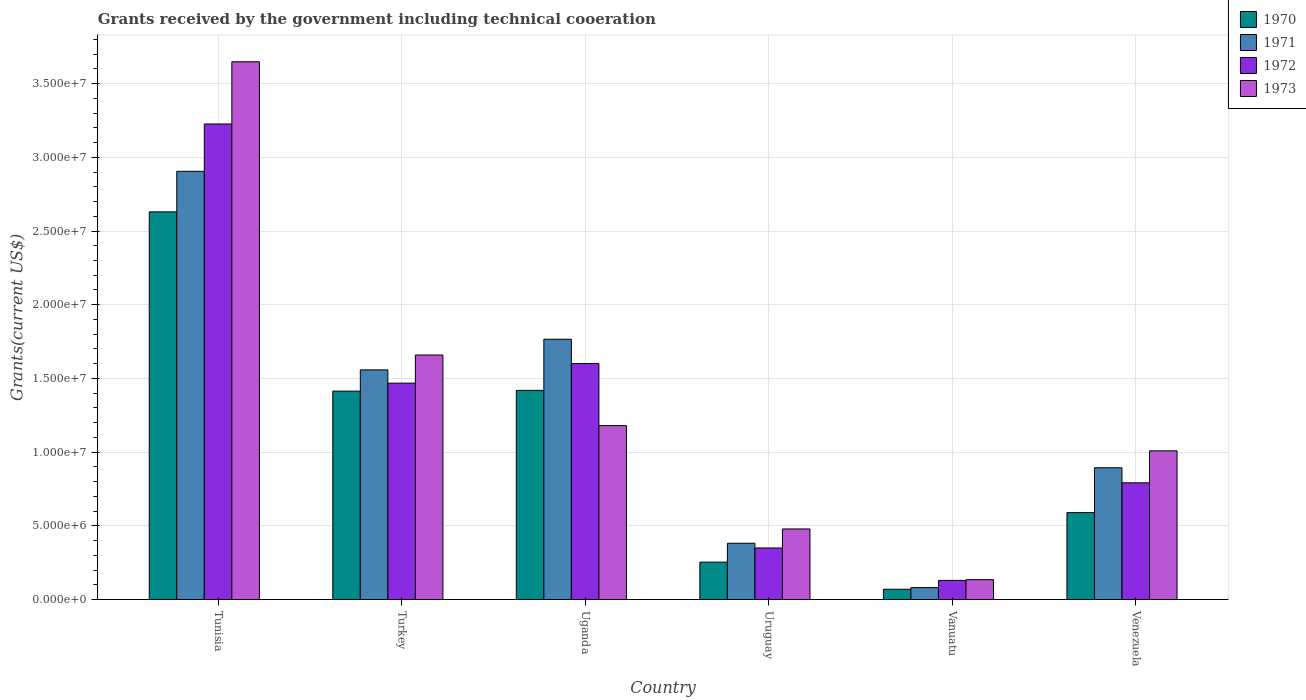How many groups of bars are there?
Provide a succinct answer. 6. Are the number of bars per tick equal to the number of legend labels?
Give a very brief answer. Yes. Are the number of bars on each tick of the X-axis equal?
Give a very brief answer. Yes. How many bars are there on the 4th tick from the right?
Your answer should be very brief. 4. What is the label of the 6th group of bars from the left?
Your answer should be very brief. Venezuela. What is the total grants received by the government in 1973 in Turkey?
Provide a succinct answer. 1.66e+07. Across all countries, what is the maximum total grants received by the government in 1973?
Your response must be concise. 3.65e+07. Across all countries, what is the minimum total grants received by the government in 1973?
Provide a succinct answer. 1.35e+06. In which country was the total grants received by the government in 1970 maximum?
Give a very brief answer. Tunisia. In which country was the total grants received by the government in 1972 minimum?
Provide a short and direct response. Vanuatu. What is the total total grants received by the government in 1973 in the graph?
Your response must be concise. 8.11e+07. What is the difference between the total grants received by the government in 1972 in Turkey and that in Vanuatu?
Provide a succinct answer. 1.34e+07. What is the difference between the total grants received by the government in 1973 in Uruguay and the total grants received by the government in 1970 in Venezuela?
Your response must be concise. -1.11e+06. What is the average total grants received by the government in 1973 per country?
Your answer should be very brief. 1.35e+07. In how many countries, is the total grants received by the government in 1971 greater than 2000000 US$?
Ensure brevity in your answer.  5. What is the ratio of the total grants received by the government in 1972 in Turkey to that in Venezuela?
Make the answer very short. 1.85. Is the total grants received by the government in 1972 in Tunisia less than that in Uganda?
Your response must be concise. No. What is the difference between the highest and the second highest total grants received by the government in 1973?
Ensure brevity in your answer.  1.99e+07. What is the difference between the highest and the lowest total grants received by the government in 1970?
Offer a terse response. 2.56e+07. In how many countries, is the total grants received by the government in 1971 greater than the average total grants received by the government in 1971 taken over all countries?
Offer a very short reply. 3. Is the sum of the total grants received by the government in 1971 in Tunisia and Uruguay greater than the maximum total grants received by the government in 1972 across all countries?
Offer a terse response. Yes. Are the values on the major ticks of Y-axis written in scientific E-notation?
Make the answer very short. Yes. Does the graph contain any zero values?
Your response must be concise. No. Where does the legend appear in the graph?
Your answer should be very brief. Top right. What is the title of the graph?
Provide a short and direct response. Grants received by the government including technical cooeration. Does "1982" appear as one of the legend labels in the graph?
Provide a short and direct response. No. What is the label or title of the Y-axis?
Your answer should be very brief. Grants(current US$). What is the Grants(current US$) in 1970 in Tunisia?
Your answer should be very brief. 2.63e+07. What is the Grants(current US$) in 1971 in Tunisia?
Provide a succinct answer. 2.90e+07. What is the Grants(current US$) of 1972 in Tunisia?
Provide a short and direct response. 3.23e+07. What is the Grants(current US$) of 1973 in Tunisia?
Keep it short and to the point. 3.65e+07. What is the Grants(current US$) of 1970 in Turkey?
Provide a succinct answer. 1.41e+07. What is the Grants(current US$) in 1971 in Turkey?
Your response must be concise. 1.56e+07. What is the Grants(current US$) of 1972 in Turkey?
Make the answer very short. 1.47e+07. What is the Grants(current US$) in 1973 in Turkey?
Offer a terse response. 1.66e+07. What is the Grants(current US$) of 1970 in Uganda?
Your answer should be compact. 1.42e+07. What is the Grants(current US$) of 1971 in Uganda?
Give a very brief answer. 1.77e+07. What is the Grants(current US$) of 1972 in Uganda?
Provide a succinct answer. 1.60e+07. What is the Grants(current US$) in 1973 in Uganda?
Give a very brief answer. 1.18e+07. What is the Grants(current US$) in 1970 in Uruguay?
Provide a short and direct response. 2.54e+06. What is the Grants(current US$) in 1971 in Uruguay?
Give a very brief answer. 3.82e+06. What is the Grants(current US$) in 1972 in Uruguay?
Provide a succinct answer. 3.50e+06. What is the Grants(current US$) of 1973 in Uruguay?
Make the answer very short. 4.79e+06. What is the Grants(current US$) of 1970 in Vanuatu?
Offer a very short reply. 7.00e+05. What is the Grants(current US$) in 1971 in Vanuatu?
Your answer should be compact. 8.10e+05. What is the Grants(current US$) of 1972 in Vanuatu?
Offer a terse response. 1.30e+06. What is the Grants(current US$) of 1973 in Vanuatu?
Offer a very short reply. 1.35e+06. What is the Grants(current US$) of 1970 in Venezuela?
Provide a short and direct response. 5.90e+06. What is the Grants(current US$) in 1971 in Venezuela?
Your answer should be very brief. 8.94e+06. What is the Grants(current US$) of 1972 in Venezuela?
Keep it short and to the point. 7.92e+06. What is the Grants(current US$) in 1973 in Venezuela?
Your answer should be very brief. 1.01e+07. Across all countries, what is the maximum Grants(current US$) in 1970?
Your answer should be very brief. 2.63e+07. Across all countries, what is the maximum Grants(current US$) in 1971?
Your answer should be compact. 2.90e+07. Across all countries, what is the maximum Grants(current US$) of 1972?
Provide a succinct answer. 3.23e+07. Across all countries, what is the maximum Grants(current US$) in 1973?
Your answer should be very brief. 3.65e+07. Across all countries, what is the minimum Grants(current US$) of 1970?
Offer a very short reply. 7.00e+05. Across all countries, what is the minimum Grants(current US$) in 1971?
Your answer should be compact. 8.10e+05. Across all countries, what is the minimum Grants(current US$) of 1972?
Your answer should be compact. 1.30e+06. Across all countries, what is the minimum Grants(current US$) of 1973?
Your response must be concise. 1.35e+06. What is the total Grants(current US$) in 1970 in the graph?
Offer a terse response. 6.38e+07. What is the total Grants(current US$) of 1971 in the graph?
Provide a short and direct response. 7.59e+07. What is the total Grants(current US$) of 1972 in the graph?
Your response must be concise. 7.57e+07. What is the total Grants(current US$) of 1973 in the graph?
Give a very brief answer. 8.11e+07. What is the difference between the Grants(current US$) in 1970 in Tunisia and that in Turkey?
Offer a terse response. 1.22e+07. What is the difference between the Grants(current US$) of 1971 in Tunisia and that in Turkey?
Keep it short and to the point. 1.35e+07. What is the difference between the Grants(current US$) in 1972 in Tunisia and that in Turkey?
Provide a succinct answer. 1.76e+07. What is the difference between the Grants(current US$) in 1973 in Tunisia and that in Turkey?
Offer a very short reply. 1.99e+07. What is the difference between the Grants(current US$) in 1970 in Tunisia and that in Uganda?
Offer a very short reply. 1.21e+07. What is the difference between the Grants(current US$) of 1971 in Tunisia and that in Uganda?
Give a very brief answer. 1.14e+07. What is the difference between the Grants(current US$) of 1972 in Tunisia and that in Uganda?
Provide a succinct answer. 1.62e+07. What is the difference between the Grants(current US$) in 1973 in Tunisia and that in Uganda?
Your response must be concise. 2.47e+07. What is the difference between the Grants(current US$) of 1970 in Tunisia and that in Uruguay?
Your response must be concise. 2.38e+07. What is the difference between the Grants(current US$) of 1971 in Tunisia and that in Uruguay?
Your answer should be very brief. 2.52e+07. What is the difference between the Grants(current US$) of 1972 in Tunisia and that in Uruguay?
Ensure brevity in your answer.  2.88e+07. What is the difference between the Grants(current US$) of 1973 in Tunisia and that in Uruguay?
Make the answer very short. 3.17e+07. What is the difference between the Grants(current US$) in 1970 in Tunisia and that in Vanuatu?
Give a very brief answer. 2.56e+07. What is the difference between the Grants(current US$) in 1971 in Tunisia and that in Vanuatu?
Your answer should be very brief. 2.82e+07. What is the difference between the Grants(current US$) in 1972 in Tunisia and that in Vanuatu?
Offer a very short reply. 3.10e+07. What is the difference between the Grants(current US$) of 1973 in Tunisia and that in Vanuatu?
Your answer should be compact. 3.51e+07. What is the difference between the Grants(current US$) of 1970 in Tunisia and that in Venezuela?
Your response must be concise. 2.04e+07. What is the difference between the Grants(current US$) in 1971 in Tunisia and that in Venezuela?
Your answer should be compact. 2.01e+07. What is the difference between the Grants(current US$) of 1972 in Tunisia and that in Venezuela?
Ensure brevity in your answer.  2.43e+07. What is the difference between the Grants(current US$) in 1973 in Tunisia and that in Venezuela?
Give a very brief answer. 2.64e+07. What is the difference between the Grants(current US$) of 1971 in Turkey and that in Uganda?
Your answer should be very brief. -2.08e+06. What is the difference between the Grants(current US$) in 1972 in Turkey and that in Uganda?
Ensure brevity in your answer.  -1.33e+06. What is the difference between the Grants(current US$) of 1973 in Turkey and that in Uganda?
Provide a succinct answer. 4.79e+06. What is the difference between the Grants(current US$) in 1970 in Turkey and that in Uruguay?
Provide a succinct answer. 1.16e+07. What is the difference between the Grants(current US$) of 1971 in Turkey and that in Uruguay?
Provide a short and direct response. 1.18e+07. What is the difference between the Grants(current US$) in 1972 in Turkey and that in Uruguay?
Provide a short and direct response. 1.12e+07. What is the difference between the Grants(current US$) of 1973 in Turkey and that in Uruguay?
Provide a succinct answer. 1.18e+07. What is the difference between the Grants(current US$) in 1970 in Turkey and that in Vanuatu?
Give a very brief answer. 1.34e+07. What is the difference between the Grants(current US$) of 1971 in Turkey and that in Vanuatu?
Your answer should be very brief. 1.48e+07. What is the difference between the Grants(current US$) of 1972 in Turkey and that in Vanuatu?
Your answer should be very brief. 1.34e+07. What is the difference between the Grants(current US$) in 1973 in Turkey and that in Vanuatu?
Your answer should be compact. 1.52e+07. What is the difference between the Grants(current US$) in 1970 in Turkey and that in Venezuela?
Provide a short and direct response. 8.24e+06. What is the difference between the Grants(current US$) in 1971 in Turkey and that in Venezuela?
Give a very brief answer. 6.64e+06. What is the difference between the Grants(current US$) in 1972 in Turkey and that in Venezuela?
Your response must be concise. 6.76e+06. What is the difference between the Grants(current US$) in 1973 in Turkey and that in Venezuela?
Offer a very short reply. 6.50e+06. What is the difference between the Grants(current US$) of 1970 in Uganda and that in Uruguay?
Keep it short and to the point. 1.16e+07. What is the difference between the Grants(current US$) in 1971 in Uganda and that in Uruguay?
Your answer should be very brief. 1.38e+07. What is the difference between the Grants(current US$) of 1972 in Uganda and that in Uruguay?
Your answer should be compact. 1.25e+07. What is the difference between the Grants(current US$) of 1973 in Uganda and that in Uruguay?
Provide a short and direct response. 7.01e+06. What is the difference between the Grants(current US$) in 1970 in Uganda and that in Vanuatu?
Your answer should be very brief. 1.35e+07. What is the difference between the Grants(current US$) in 1971 in Uganda and that in Vanuatu?
Offer a terse response. 1.68e+07. What is the difference between the Grants(current US$) in 1972 in Uganda and that in Vanuatu?
Your response must be concise. 1.47e+07. What is the difference between the Grants(current US$) of 1973 in Uganda and that in Vanuatu?
Your response must be concise. 1.04e+07. What is the difference between the Grants(current US$) of 1970 in Uganda and that in Venezuela?
Keep it short and to the point. 8.29e+06. What is the difference between the Grants(current US$) in 1971 in Uganda and that in Venezuela?
Keep it short and to the point. 8.72e+06. What is the difference between the Grants(current US$) of 1972 in Uganda and that in Venezuela?
Your answer should be very brief. 8.09e+06. What is the difference between the Grants(current US$) of 1973 in Uganda and that in Venezuela?
Your response must be concise. 1.71e+06. What is the difference between the Grants(current US$) of 1970 in Uruguay and that in Vanuatu?
Give a very brief answer. 1.84e+06. What is the difference between the Grants(current US$) in 1971 in Uruguay and that in Vanuatu?
Provide a short and direct response. 3.01e+06. What is the difference between the Grants(current US$) in 1972 in Uruguay and that in Vanuatu?
Give a very brief answer. 2.20e+06. What is the difference between the Grants(current US$) of 1973 in Uruguay and that in Vanuatu?
Make the answer very short. 3.44e+06. What is the difference between the Grants(current US$) of 1970 in Uruguay and that in Venezuela?
Your answer should be compact. -3.36e+06. What is the difference between the Grants(current US$) in 1971 in Uruguay and that in Venezuela?
Give a very brief answer. -5.12e+06. What is the difference between the Grants(current US$) of 1972 in Uruguay and that in Venezuela?
Ensure brevity in your answer.  -4.42e+06. What is the difference between the Grants(current US$) of 1973 in Uruguay and that in Venezuela?
Your response must be concise. -5.30e+06. What is the difference between the Grants(current US$) of 1970 in Vanuatu and that in Venezuela?
Offer a very short reply. -5.20e+06. What is the difference between the Grants(current US$) in 1971 in Vanuatu and that in Venezuela?
Your answer should be very brief. -8.13e+06. What is the difference between the Grants(current US$) in 1972 in Vanuatu and that in Venezuela?
Provide a short and direct response. -6.62e+06. What is the difference between the Grants(current US$) of 1973 in Vanuatu and that in Venezuela?
Make the answer very short. -8.74e+06. What is the difference between the Grants(current US$) of 1970 in Tunisia and the Grants(current US$) of 1971 in Turkey?
Keep it short and to the point. 1.07e+07. What is the difference between the Grants(current US$) in 1970 in Tunisia and the Grants(current US$) in 1972 in Turkey?
Offer a very short reply. 1.16e+07. What is the difference between the Grants(current US$) of 1970 in Tunisia and the Grants(current US$) of 1973 in Turkey?
Offer a very short reply. 9.71e+06. What is the difference between the Grants(current US$) in 1971 in Tunisia and the Grants(current US$) in 1972 in Turkey?
Offer a very short reply. 1.44e+07. What is the difference between the Grants(current US$) in 1971 in Tunisia and the Grants(current US$) in 1973 in Turkey?
Give a very brief answer. 1.25e+07. What is the difference between the Grants(current US$) of 1972 in Tunisia and the Grants(current US$) of 1973 in Turkey?
Keep it short and to the point. 1.57e+07. What is the difference between the Grants(current US$) of 1970 in Tunisia and the Grants(current US$) of 1971 in Uganda?
Provide a succinct answer. 8.64e+06. What is the difference between the Grants(current US$) of 1970 in Tunisia and the Grants(current US$) of 1972 in Uganda?
Your answer should be very brief. 1.03e+07. What is the difference between the Grants(current US$) in 1970 in Tunisia and the Grants(current US$) in 1973 in Uganda?
Your response must be concise. 1.45e+07. What is the difference between the Grants(current US$) in 1971 in Tunisia and the Grants(current US$) in 1972 in Uganda?
Make the answer very short. 1.30e+07. What is the difference between the Grants(current US$) in 1971 in Tunisia and the Grants(current US$) in 1973 in Uganda?
Give a very brief answer. 1.72e+07. What is the difference between the Grants(current US$) in 1972 in Tunisia and the Grants(current US$) in 1973 in Uganda?
Keep it short and to the point. 2.05e+07. What is the difference between the Grants(current US$) in 1970 in Tunisia and the Grants(current US$) in 1971 in Uruguay?
Offer a very short reply. 2.25e+07. What is the difference between the Grants(current US$) of 1970 in Tunisia and the Grants(current US$) of 1972 in Uruguay?
Make the answer very short. 2.28e+07. What is the difference between the Grants(current US$) in 1970 in Tunisia and the Grants(current US$) in 1973 in Uruguay?
Your answer should be compact. 2.15e+07. What is the difference between the Grants(current US$) in 1971 in Tunisia and the Grants(current US$) in 1972 in Uruguay?
Your answer should be very brief. 2.56e+07. What is the difference between the Grants(current US$) of 1971 in Tunisia and the Grants(current US$) of 1973 in Uruguay?
Your answer should be very brief. 2.43e+07. What is the difference between the Grants(current US$) in 1972 in Tunisia and the Grants(current US$) in 1973 in Uruguay?
Your response must be concise. 2.75e+07. What is the difference between the Grants(current US$) of 1970 in Tunisia and the Grants(current US$) of 1971 in Vanuatu?
Keep it short and to the point. 2.55e+07. What is the difference between the Grants(current US$) in 1970 in Tunisia and the Grants(current US$) in 1972 in Vanuatu?
Offer a very short reply. 2.50e+07. What is the difference between the Grants(current US$) in 1970 in Tunisia and the Grants(current US$) in 1973 in Vanuatu?
Offer a very short reply. 2.50e+07. What is the difference between the Grants(current US$) of 1971 in Tunisia and the Grants(current US$) of 1972 in Vanuatu?
Ensure brevity in your answer.  2.78e+07. What is the difference between the Grants(current US$) in 1971 in Tunisia and the Grants(current US$) in 1973 in Vanuatu?
Ensure brevity in your answer.  2.77e+07. What is the difference between the Grants(current US$) of 1972 in Tunisia and the Grants(current US$) of 1973 in Vanuatu?
Make the answer very short. 3.09e+07. What is the difference between the Grants(current US$) in 1970 in Tunisia and the Grants(current US$) in 1971 in Venezuela?
Ensure brevity in your answer.  1.74e+07. What is the difference between the Grants(current US$) of 1970 in Tunisia and the Grants(current US$) of 1972 in Venezuela?
Your response must be concise. 1.84e+07. What is the difference between the Grants(current US$) of 1970 in Tunisia and the Grants(current US$) of 1973 in Venezuela?
Ensure brevity in your answer.  1.62e+07. What is the difference between the Grants(current US$) of 1971 in Tunisia and the Grants(current US$) of 1972 in Venezuela?
Provide a short and direct response. 2.11e+07. What is the difference between the Grants(current US$) in 1971 in Tunisia and the Grants(current US$) in 1973 in Venezuela?
Offer a terse response. 1.90e+07. What is the difference between the Grants(current US$) of 1972 in Tunisia and the Grants(current US$) of 1973 in Venezuela?
Give a very brief answer. 2.22e+07. What is the difference between the Grants(current US$) of 1970 in Turkey and the Grants(current US$) of 1971 in Uganda?
Your response must be concise. -3.52e+06. What is the difference between the Grants(current US$) in 1970 in Turkey and the Grants(current US$) in 1972 in Uganda?
Provide a succinct answer. -1.87e+06. What is the difference between the Grants(current US$) of 1970 in Turkey and the Grants(current US$) of 1973 in Uganda?
Your response must be concise. 2.34e+06. What is the difference between the Grants(current US$) of 1971 in Turkey and the Grants(current US$) of 1972 in Uganda?
Make the answer very short. -4.30e+05. What is the difference between the Grants(current US$) in 1971 in Turkey and the Grants(current US$) in 1973 in Uganda?
Your answer should be compact. 3.78e+06. What is the difference between the Grants(current US$) of 1972 in Turkey and the Grants(current US$) of 1973 in Uganda?
Ensure brevity in your answer.  2.88e+06. What is the difference between the Grants(current US$) of 1970 in Turkey and the Grants(current US$) of 1971 in Uruguay?
Offer a very short reply. 1.03e+07. What is the difference between the Grants(current US$) in 1970 in Turkey and the Grants(current US$) in 1972 in Uruguay?
Offer a very short reply. 1.06e+07. What is the difference between the Grants(current US$) in 1970 in Turkey and the Grants(current US$) in 1973 in Uruguay?
Offer a very short reply. 9.35e+06. What is the difference between the Grants(current US$) in 1971 in Turkey and the Grants(current US$) in 1972 in Uruguay?
Provide a succinct answer. 1.21e+07. What is the difference between the Grants(current US$) in 1971 in Turkey and the Grants(current US$) in 1973 in Uruguay?
Keep it short and to the point. 1.08e+07. What is the difference between the Grants(current US$) of 1972 in Turkey and the Grants(current US$) of 1973 in Uruguay?
Ensure brevity in your answer.  9.89e+06. What is the difference between the Grants(current US$) of 1970 in Turkey and the Grants(current US$) of 1971 in Vanuatu?
Offer a very short reply. 1.33e+07. What is the difference between the Grants(current US$) of 1970 in Turkey and the Grants(current US$) of 1972 in Vanuatu?
Your answer should be compact. 1.28e+07. What is the difference between the Grants(current US$) of 1970 in Turkey and the Grants(current US$) of 1973 in Vanuatu?
Make the answer very short. 1.28e+07. What is the difference between the Grants(current US$) of 1971 in Turkey and the Grants(current US$) of 1972 in Vanuatu?
Your answer should be very brief. 1.43e+07. What is the difference between the Grants(current US$) in 1971 in Turkey and the Grants(current US$) in 1973 in Vanuatu?
Provide a short and direct response. 1.42e+07. What is the difference between the Grants(current US$) in 1972 in Turkey and the Grants(current US$) in 1973 in Vanuatu?
Your answer should be compact. 1.33e+07. What is the difference between the Grants(current US$) of 1970 in Turkey and the Grants(current US$) of 1971 in Venezuela?
Make the answer very short. 5.20e+06. What is the difference between the Grants(current US$) in 1970 in Turkey and the Grants(current US$) in 1972 in Venezuela?
Your answer should be very brief. 6.22e+06. What is the difference between the Grants(current US$) in 1970 in Turkey and the Grants(current US$) in 1973 in Venezuela?
Provide a short and direct response. 4.05e+06. What is the difference between the Grants(current US$) in 1971 in Turkey and the Grants(current US$) in 1972 in Venezuela?
Give a very brief answer. 7.66e+06. What is the difference between the Grants(current US$) in 1971 in Turkey and the Grants(current US$) in 1973 in Venezuela?
Ensure brevity in your answer.  5.49e+06. What is the difference between the Grants(current US$) in 1972 in Turkey and the Grants(current US$) in 1973 in Venezuela?
Ensure brevity in your answer.  4.59e+06. What is the difference between the Grants(current US$) of 1970 in Uganda and the Grants(current US$) of 1971 in Uruguay?
Your response must be concise. 1.04e+07. What is the difference between the Grants(current US$) of 1970 in Uganda and the Grants(current US$) of 1972 in Uruguay?
Keep it short and to the point. 1.07e+07. What is the difference between the Grants(current US$) of 1970 in Uganda and the Grants(current US$) of 1973 in Uruguay?
Ensure brevity in your answer.  9.40e+06. What is the difference between the Grants(current US$) of 1971 in Uganda and the Grants(current US$) of 1972 in Uruguay?
Ensure brevity in your answer.  1.42e+07. What is the difference between the Grants(current US$) in 1971 in Uganda and the Grants(current US$) in 1973 in Uruguay?
Ensure brevity in your answer.  1.29e+07. What is the difference between the Grants(current US$) of 1972 in Uganda and the Grants(current US$) of 1973 in Uruguay?
Your answer should be compact. 1.12e+07. What is the difference between the Grants(current US$) in 1970 in Uganda and the Grants(current US$) in 1971 in Vanuatu?
Provide a short and direct response. 1.34e+07. What is the difference between the Grants(current US$) of 1970 in Uganda and the Grants(current US$) of 1972 in Vanuatu?
Your answer should be very brief. 1.29e+07. What is the difference between the Grants(current US$) in 1970 in Uganda and the Grants(current US$) in 1973 in Vanuatu?
Offer a very short reply. 1.28e+07. What is the difference between the Grants(current US$) in 1971 in Uganda and the Grants(current US$) in 1972 in Vanuatu?
Your answer should be very brief. 1.64e+07. What is the difference between the Grants(current US$) of 1971 in Uganda and the Grants(current US$) of 1973 in Vanuatu?
Provide a succinct answer. 1.63e+07. What is the difference between the Grants(current US$) of 1972 in Uganda and the Grants(current US$) of 1973 in Vanuatu?
Your answer should be very brief. 1.47e+07. What is the difference between the Grants(current US$) in 1970 in Uganda and the Grants(current US$) in 1971 in Venezuela?
Ensure brevity in your answer.  5.25e+06. What is the difference between the Grants(current US$) of 1970 in Uganda and the Grants(current US$) of 1972 in Venezuela?
Provide a succinct answer. 6.27e+06. What is the difference between the Grants(current US$) of 1970 in Uganda and the Grants(current US$) of 1973 in Venezuela?
Make the answer very short. 4.10e+06. What is the difference between the Grants(current US$) of 1971 in Uganda and the Grants(current US$) of 1972 in Venezuela?
Provide a short and direct response. 9.74e+06. What is the difference between the Grants(current US$) of 1971 in Uganda and the Grants(current US$) of 1973 in Venezuela?
Your response must be concise. 7.57e+06. What is the difference between the Grants(current US$) in 1972 in Uganda and the Grants(current US$) in 1973 in Venezuela?
Keep it short and to the point. 5.92e+06. What is the difference between the Grants(current US$) in 1970 in Uruguay and the Grants(current US$) in 1971 in Vanuatu?
Your response must be concise. 1.73e+06. What is the difference between the Grants(current US$) of 1970 in Uruguay and the Grants(current US$) of 1972 in Vanuatu?
Keep it short and to the point. 1.24e+06. What is the difference between the Grants(current US$) in 1970 in Uruguay and the Grants(current US$) in 1973 in Vanuatu?
Offer a very short reply. 1.19e+06. What is the difference between the Grants(current US$) in 1971 in Uruguay and the Grants(current US$) in 1972 in Vanuatu?
Give a very brief answer. 2.52e+06. What is the difference between the Grants(current US$) of 1971 in Uruguay and the Grants(current US$) of 1973 in Vanuatu?
Give a very brief answer. 2.47e+06. What is the difference between the Grants(current US$) of 1972 in Uruguay and the Grants(current US$) of 1973 in Vanuatu?
Your answer should be very brief. 2.15e+06. What is the difference between the Grants(current US$) in 1970 in Uruguay and the Grants(current US$) in 1971 in Venezuela?
Your response must be concise. -6.40e+06. What is the difference between the Grants(current US$) of 1970 in Uruguay and the Grants(current US$) of 1972 in Venezuela?
Offer a terse response. -5.38e+06. What is the difference between the Grants(current US$) in 1970 in Uruguay and the Grants(current US$) in 1973 in Venezuela?
Your answer should be compact. -7.55e+06. What is the difference between the Grants(current US$) of 1971 in Uruguay and the Grants(current US$) of 1972 in Venezuela?
Offer a very short reply. -4.10e+06. What is the difference between the Grants(current US$) in 1971 in Uruguay and the Grants(current US$) in 1973 in Venezuela?
Your response must be concise. -6.27e+06. What is the difference between the Grants(current US$) in 1972 in Uruguay and the Grants(current US$) in 1973 in Venezuela?
Provide a short and direct response. -6.59e+06. What is the difference between the Grants(current US$) in 1970 in Vanuatu and the Grants(current US$) in 1971 in Venezuela?
Provide a succinct answer. -8.24e+06. What is the difference between the Grants(current US$) in 1970 in Vanuatu and the Grants(current US$) in 1972 in Venezuela?
Ensure brevity in your answer.  -7.22e+06. What is the difference between the Grants(current US$) of 1970 in Vanuatu and the Grants(current US$) of 1973 in Venezuela?
Your answer should be compact. -9.39e+06. What is the difference between the Grants(current US$) of 1971 in Vanuatu and the Grants(current US$) of 1972 in Venezuela?
Provide a succinct answer. -7.11e+06. What is the difference between the Grants(current US$) of 1971 in Vanuatu and the Grants(current US$) of 1973 in Venezuela?
Offer a very short reply. -9.28e+06. What is the difference between the Grants(current US$) in 1972 in Vanuatu and the Grants(current US$) in 1973 in Venezuela?
Your answer should be very brief. -8.79e+06. What is the average Grants(current US$) of 1970 per country?
Offer a terse response. 1.06e+07. What is the average Grants(current US$) in 1971 per country?
Your response must be concise. 1.26e+07. What is the average Grants(current US$) of 1972 per country?
Your answer should be compact. 1.26e+07. What is the average Grants(current US$) in 1973 per country?
Offer a terse response. 1.35e+07. What is the difference between the Grants(current US$) of 1970 and Grants(current US$) of 1971 in Tunisia?
Give a very brief answer. -2.75e+06. What is the difference between the Grants(current US$) in 1970 and Grants(current US$) in 1972 in Tunisia?
Your response must be concise. -5.96e+06. What is the difference between the Grants(current US$) in 1970 and Grants(current US$) in 1973 in Tunisia?
Give a very brief answer. -1.02e+07. What is the difference between the Grants(current US$) of 1971 and Grants(current US$) of 1972 in Tunisia?
Your answer should be compact. -3.21e+06. What is the difference between the Grants(current US$) in 1971 and Grants(current US$) in 1973 in Tunisia?
Your answer should be compact. -7.43e+06. What is the difference between the Grants(current US$) in 1972 and Grants(current US$) in 1973 in Tunisia?
Give a very brief answer. -4.22e+06. What is the difference between the Grants(current US$) of 1970 and Grants(current US$) of 1971 in Turkey?
Ensure brevity in your answer.  -1.44e+06. What is the difference between the Grants(current US$) in 1970 and Grants(current US$) in 1972 in Turkey?
Your answer should be compact. -5.40e+05. What is the difference between the Grants(current US$) of 1970 and Grants(current US$) of 1973 in Turkey?
Ensure brevity in your answer.  -2.45e+06. What is the difference between the Grants(current US$) in 1971 and Grants(current US$) in 1973 in Turkey?
Offer a very short reply. -1.01e+06. What is the difference between the Grants(current US$) of 1972 and Grants(current US$) of 1973 in Turkey?
Your answer should be very brief. -1.91e+06. What is the difference between the Grants(current US$) in 1970 and Grants(current US$) in 1971 in Uganda?
Your response must be concise. -3.47e+06. What is the difference between the Grants(current US$) of 1970 and Grants(current US$) of 1972 in Uganda?
Provide a succinct answer. -1.82e+06. What is the difference between the Grants(current US$) of 1970 and Grants(current US$) of 1973 in Uganda?
Ensure brevity in your answer.  2.39e+06. What is the difference between the Grants(current US$) of 1971 and Grants(current US$) of 1972 in Uganda?
Offer a terse response. 1.65e+06. What is the difference between the Grants(current US$) of 1971 and Grants(current US$) of 1973 in Uganda?
Your response must be concise. 5.86e+06. What is the difference between the Grants(current US$) in 1972 and Grants(current US$) in 1973 in Uganda?
Provide a succinct answer. 4.21e+06. What is the difference between the Grants(current US$) of 1970 and Grants(current US$) of 1971 in Uruguay?
Give a very brief answer. -1.28e+06. What is the difference between the Grants(current US$) in 1970 and Grants(current US$) in 1972 in Uruguay?
Provide a short and direct response. -9.60e+05. What is the difference between the Grants(current US$) of 1970 and Grants(current US$) of 1973 in Uruguay?
Your answer should be compact. -2.25e+06. What is the difference between the Grants(current US$) of 1971 and Grants(current US$) of 1972 in Uruguay?
Give a very brief answer. 3.20e+05. What is the difference between the Grants(current US$) in 1971 and Grants(current US$) in 1973 in Uruguay?
Your answer should be very brief. -9.70e+05. What is the difference between the Grants(current US$) of 1972 and Grants(current US$) of 1973 in Uruguay?
Keep it short and to the point. -1.29e+06. What is the difference between the Grants(current US$) in 1970 and Grants(current US$) in 1972 in Vanuatu?
Your response must be concise. -6.00e+05. What is the difference between the Grants(current US$) of 1970 and Grants(current US$) of 1973 in Vanuatu?
Provide a short and direct response. -6.50e+05. What is the difference between the Grants(current US$) in 1971 and Grants(current US$) in 1972 in Vanuatu?
Provide a succinct answer. -4.90e+05. What is the difference between the Grants(current US$) of 1971 and Grants(current US$) of 1973 in Vanuatu?
Provide a short and direct response. -5.40e+05. What is the difference between the Grants(current US$) in 1970 and Grants(current US$) in 1971 in Venezuela?
Offer a terse response. -3.04e+06. What is the difference between the Grants(current US$) of 1970 and Grants(current US$) of 1972 in Venezuela?
Your answer should be compact. -2.02e+06. What is the difference between the Grants(current US$) in 1970 and Grants(current US$) in 1973 in Venezuela?
Offer a terse response. -4.19e+06. What is the difference between the Grants(current US$) of 1971 and Grants(current US$) of 1972 in Venezuela?
Provide a short and direct response. 1.02e+06. What is the difference between the Grants(current US$) in 1971 and Grants(current US$) in 1973 in Venezuela?
Provide a succinct answer. -1.15e+06. What is the difference between the Grants(current US$) of 1972 and Grants(current US$) of 1973 in Venezuela?
Make the answer very short. -2.17e+06. What is the ratio of the Grants(current US$) in 1970 in Tunisia to that in Turkey?
Provide a succinct answer. 1.86. What is the ratio of the Grants(current US$) of 1971 in Tunisia to that in Turkey?
Offer a very short reply. 1.86. What is the ratio of the Grants(current US$) in 1972 in Tunisia to that in Turkey?
Make the answer very short. 2.2. What is the ratio of the Grants(current US$) in 1973 in Tunisia to that in Turkey?
Your response must be concise. 2.2. What is the ratio of the Grants(current US$) in 1970 in Tunisia to that in Uganda?
Offer a very short reply. 1.85. What is the ratio of the Grants(current US$) in 1971 in Tunisia to that in Uganda?
Make the answer very short. 1.65. What is the ratio of the Grants(current US$) of 1972 in Tunisia to that in Uganda?
Offer a very short reply. 2.02. What is the ratio of the Grants(current US$) of 1973 in Tunisia to that in Uganda?
Ensure brevity in your answer.  3.09. What is the ratio of the Grants(current US$) in 1970 in Tunisia to that in Uruguay?
Your answer should be very brief. 10.35. What is the ratio of the Grants(current US$) in 1971 in Tunisia to that in Uruguay?
Provide a succinct answer. 7.6. What is the ratio of the Grants(current US$) in 1972 in Tunisia to that in Uruguay?
Offer a very short reply. 9.22. What is the ratio of the Grants(current US$) in 1973 in Tunisia to that in Uruguay?
Your answer should be very brief. 7.62. What is the ratio of the Grants(current US$) of 1970 in Tunisia to that in Vanuatu?
Your answer should be compact. 37.57. What is the ratio of the Grants(current US$) in 1971 in Tunisia to that in Vanuatu?
Give a very brief answer. 35.86. What is the ratio of the Grants(current US$) of 1972 in Tunisia to that in Vanuatu?
Give a very brief answer. 24.82. What is the ratio of the Grants(current US$) in 1973 in Tunisia to that in Vanuatu?
Provide a succinct answer. 27.02. What is the ratio of the Grants(current US$) in 1970 in Tunisia to that in Venezuela?
Provide a succinct answer. 4.46. What is the ratio of the Grants(current US$) in 1971 in Tunisia to that in Venezuela?
Make the answer very short. 3.25. What is the ratio of the Grants(current US$) of 1972 in Tunisia to that in Venezuela?
Offer a very short reply. 4.07. What is the ratio of the Grants(current US$) of 1973 in Tunisia to that in Venezuela?
Your response must be concise. 3.62. What is the ratio of the Grants(current US$) of 1971 in Turkey to that in Uganda?
Give a very brief answer. 0.88. What is the ratio of the Grants(current US$) in 1972 in Turkey to that in Uganda?
Make the answer very short. 0.92. What is the ratio of the Grants(current US$) of 1973 in Turkey to that in Uganda?
Offer a very short reply. 1.41. What is the ratio of the Grants(current US$) of 1970 in Turkey to that in Uruguay?
Ensure brevity in your answer.  5.57. What is the ratio of the Grants(current US$) of 1971 in Turkey to that in Uruguay?
Offer a very short reply. 4.08. What is the ratio of the Grants(current US$) in 1972 in Turkey to that in Uruguay?
Your answer should be compact. 4.19. What is the ratio of the Grants(current US$) of 1973 in Turkey to that in Uruguay?
Give a very brief answer. 3.46. What is the ratio of the Grants(current US$) of 1970 in Turkey to that in Vanuatu?
Keep it short and to the point. 20.2. What is the ratio of the Grants(current US$) in 1971 in Turkey to that in Vanuatu?
Your answer should be compact. 19.23. What is the ratio of the Grants(current US$) in 1972 in Turkey to that in Vanuatu?
Your answer should be very brief. 11.29. What is the ratio of the Grants(current US$) in 1973 in Turkey to that in Vanuatu?
Give a very brief answer. 12.29. What is the ratio of the Grants(current US$) of 1970 in Turkey to that in Venezuela?
Keep it short and to the point. 2.4. What is the ratio of the Grants(current US$) in 1971 in Turkey to that in Venezuela?
Your answer should be compact. 1.74. What is the ratio of the Grants(current US$) in 1972 in Turkey to that in Venezuela?
Provide a short and direct response. 1.85. What is the ratio of the Grants(current US$) of 1973 in Turkey to that in Venezuela?
Your answer should be very brief. 1.64. What is the ratio of the Grants(current US$) in 1970 in Uganda to that in Uruguay?
Your answer should be compact. 5.59. What is the ratio of the Grants(current US$) in 1971 in Uganda to that in Uruguay?
Your answer should be very brief. 4.62. What is the ratio of the Grants(current US$) of 1972 in Uganda to that in Uruguay?
Ensure brevity in your answer.  4.57. What is the ratio of the Grants(current US$) in 1973 in Uganda to that in Uruguay?
Provide a short and direct response. 2.46. What is the ratio of the Grants(current US$) in 1970 in Uganda to that in Vanuatu?
Your answer should be compact. 20.27. What is the ratio of the Grants(current US$) of 1971 in Uganda to that in Vanuatu?
Your answer should be compact. 21.8. What is the ratio of the Grants(current US$) in 1972 in Uganda to that in Vanuatu?
Your answer should be compact. 12.32. What is the ratio of the Grants(current US$) of 1973 in Uganda to that in Vanuatu?
Offer a very short reply. 8.74. What is the ratio of the Grants(current US$) in 1970 in Uganda to that in Venezuela?
Ensure brevity in your answer.  2.41. What is the ratio of the Grants(current US$) of 1971 in Uganda to that in Venezuela?
Keep it short and to the point. 1.98. What is the ratio of the Grants(current US$) in 1972 in Uganda to that in Venezuela?
Offer a terse response. 2.02. What is the ratio of the Grants(current US$) of 1973 in Uganda to that in Venezuela?
Provide a short and direct response. 1.17. What is the ratio of the Grants(current US$) in 1970 in Uruguay to that in Vanuatu?
Your response must be concise. 3.63. What is the ratio of the Grants(current US$) in 1971 in Uruguay to that in Vanuatu?
Ensure brevity in your answer.  4.72. What is the ratio of the Grants(current US$) of 1972 in Uruguay to that in Vanuatu?
Provide a short and direct response. 2.69. What is the ratio of the Grants(current US$) in 1973 in Uruguay to that in Vanuatu?
Make the answer very short. 3.55. What is the ratio of the Grants(current US$) in 1970 in Uruguay to that in Venezuela?
Your response must be concise. 0.43. What is the ratio of the Grants(current US$) in 1971 in Uruguay to that in Venezuela?
Give a very brief answer. 0.43. What is the ratio of the Grants(current US$) in 1972 in Uruguay to that in Venezuela?
Your response must be concise. 0.44. What is the ratio of the Grants(current US$) in 1973 in Uruguay to that in Venezuela?
Give a very brief answer. 0.47. What is the ratio of the Grants(current US$) in 1970 in Vanuatu to that in Venezuela?
Keep it short and to the point. 0.12. What is the ratio of the Grants(current US$) in 1971 in Vanuatu to that in Venezuela?
Your response must be concise. 0.09. What is the ratio of the Grants(current US$) of 1972 in Vanuatu to that in Venezuela?
Your answer should be very brief. 0.16. What is the ratio of the Grants(current US$) in 1973 in Vanuatu to that in Venezuela?
Make the answer very short. 0.13. What is the difference between the highest and the second highest Grants(current US$) of 1970?
Make the answer very short. 1.21e+07. What is the difference between the highest and the second highest Grants(current US$) of 1971?
Keep it short and to the point. 1.14e+07. What is the difference between the highest and the second highest Grants(current US$) in 1972?
Your answer should be very brief. 1.62e+07. What is the difference between the highest and the second highest Grants(current US$) in 1973?
Your response must be concise. 1.99e+07. What is the difference between the highest and the lowest Grants(current US$) of 1970?
Your answer should be compact. 2.56e+07. What is the difference between the highest and the lowest Grants(current US$) of 1971?
Ensure brevity in your answer.  2.82e+07. What is the difference between the highest and the lowest Grants(current US$) of 1972?
Your response must be concise. 3.10e+07. What is the difference between the highest and the lowest Grants(current US$) of 1973?
Offer a terse response. 3.51e+07. 